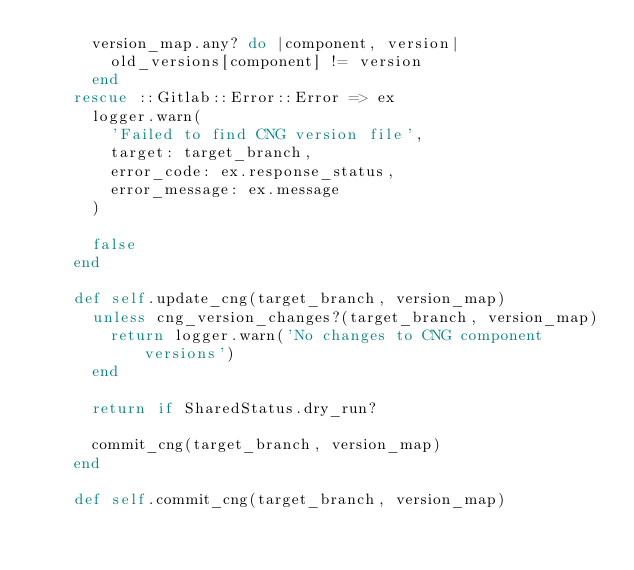<code> <loc_0><loc_0><loc_500><loc_500><_Ruby_>      version_map.any? do |component, version|
        old_versions[component] != version
      end
    rescue ::Gitlab::Error::Error => ex
      logger.warn(
        'Failed to find CNG version file',
        target: target_branch,
        error_code: ex.response_status,
        error_message: ex.message
      )

      false
    end

    def self.update_cng(target_branch, version_map)
      unless cng_version_changes?(target_branch, version_map)
        return logger.warn('No changes to CNG component versions')
      end

      return if SharedStatus.dry_run?

      commit_cng(target_branch, version_map)
    end

    def self.commit_cng(target_branch, version_map)</code> 